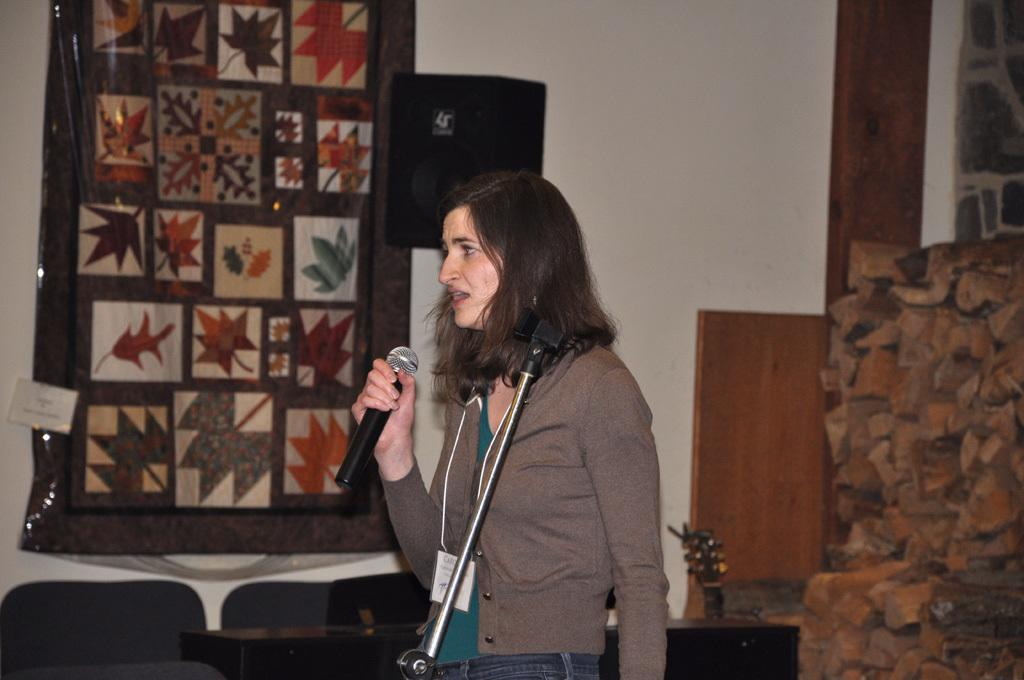Who is the main subject in the image? There is a woman in the image. What is the woman holding in the image? The woman is holding a microphone. What is the woman doing in the image? The woman is talking. What can be seen on the wall in the image? There is a picture on the wall in the image. What type of clover can be seen growing on the floor in the image? There is no clover present in the image; it is an indoor setting with a woman holding a microphone and talking. 